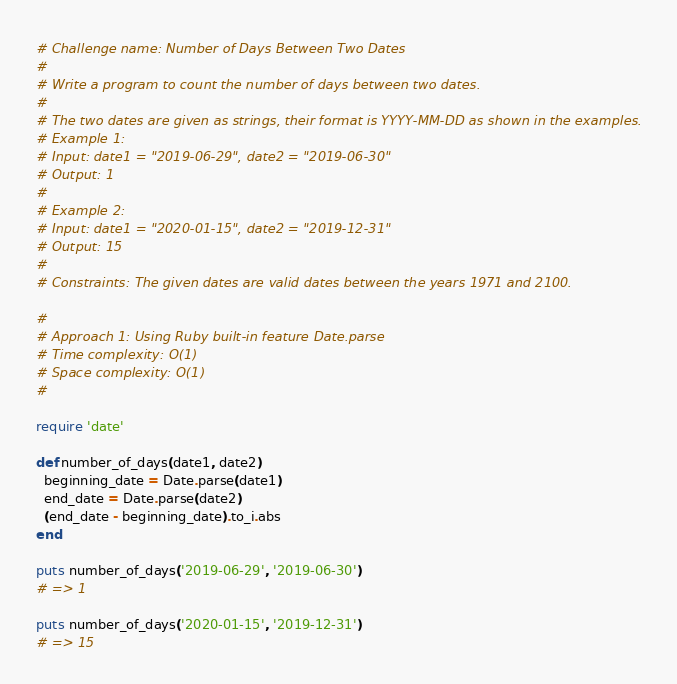<code> <loc_0><loc_0><loc_500><loc_500><_Ruby_># Challenge name: Number of Days Between Two Dates
#
# Write a program to count the number of days between two dates.
#
# The two dates are given as strings, their format is YYYY-MM-DD as shown in the examples.
# Example 1:
# Input: date1 = "2019-06-29", date2 = "2019-06-30"
# Output: 1
#
# Example 2:
# Input: date1 = "2020-01-15", date2 = "2019-12-31"
# Output: 15
#
# Constraints: The given dates are valid dates between the years 1971 and 2100.

#
# Approach 1: Using Ruby built-in feature Date.parse
# Time complexity: O(1)
# Space complexity: O(1)
#

require 'date'

def number_of_days(date1, date2)
  beginning_date = Date.parse(date1)
  end_date = Date.parse(date2)
  (end_date - beginning_date).to_i.abs
end

puts number_of_days('2019-06-29', '2019-06-30')
# => 1

puts number_of_days('2020-01-15', '2019-12-31')
# => 15
</code> 